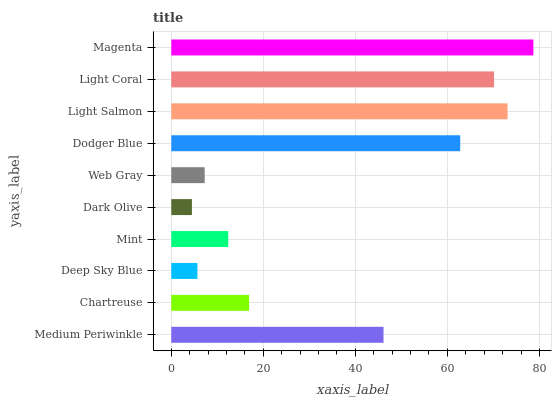Is Dark Olive the minimum?
Answer yes or no. Yes. Is Magenta the maximum?
Answer yes or no. Yes. Is Chartreuse the minimum?
Answer yes or no. No. Is Chartreuse the maximum?
Answer yes or no. No. Is Medium Periwinkle greater than Chartreuse?
Answer yes or no. Yes. Is Chartreuse less than Medium Periwinkle?
Answer yes or no. Yes. Is Chartreuse greater than Medium Periwinkle?
Answer yes or no. No. Is Medium Periwinkle less than Chartreuse?
Answer yes or no. No. Is Medium Periwinkle the high median?
Answer yes or no. Yes. Is Chartreuse the low median?
Answer yes or no. Yes. Is Light Coral the high median?
Answer yes or no. No. Is Deep Sky Blue the low median?
Answer yes or no. No. 